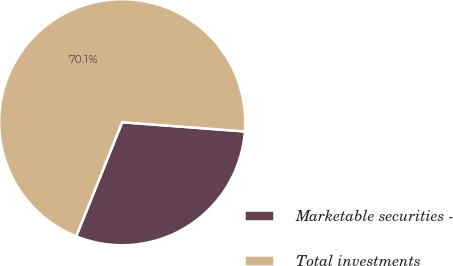Convert chart to OTSL. <chart><loc_0><loc_0><loc_500><loc_500><pie_chart><fcel>Marketable securities -<fcel>Total investments<nl><fcel>29.9%<fcel>70.1%<nl></chart> 